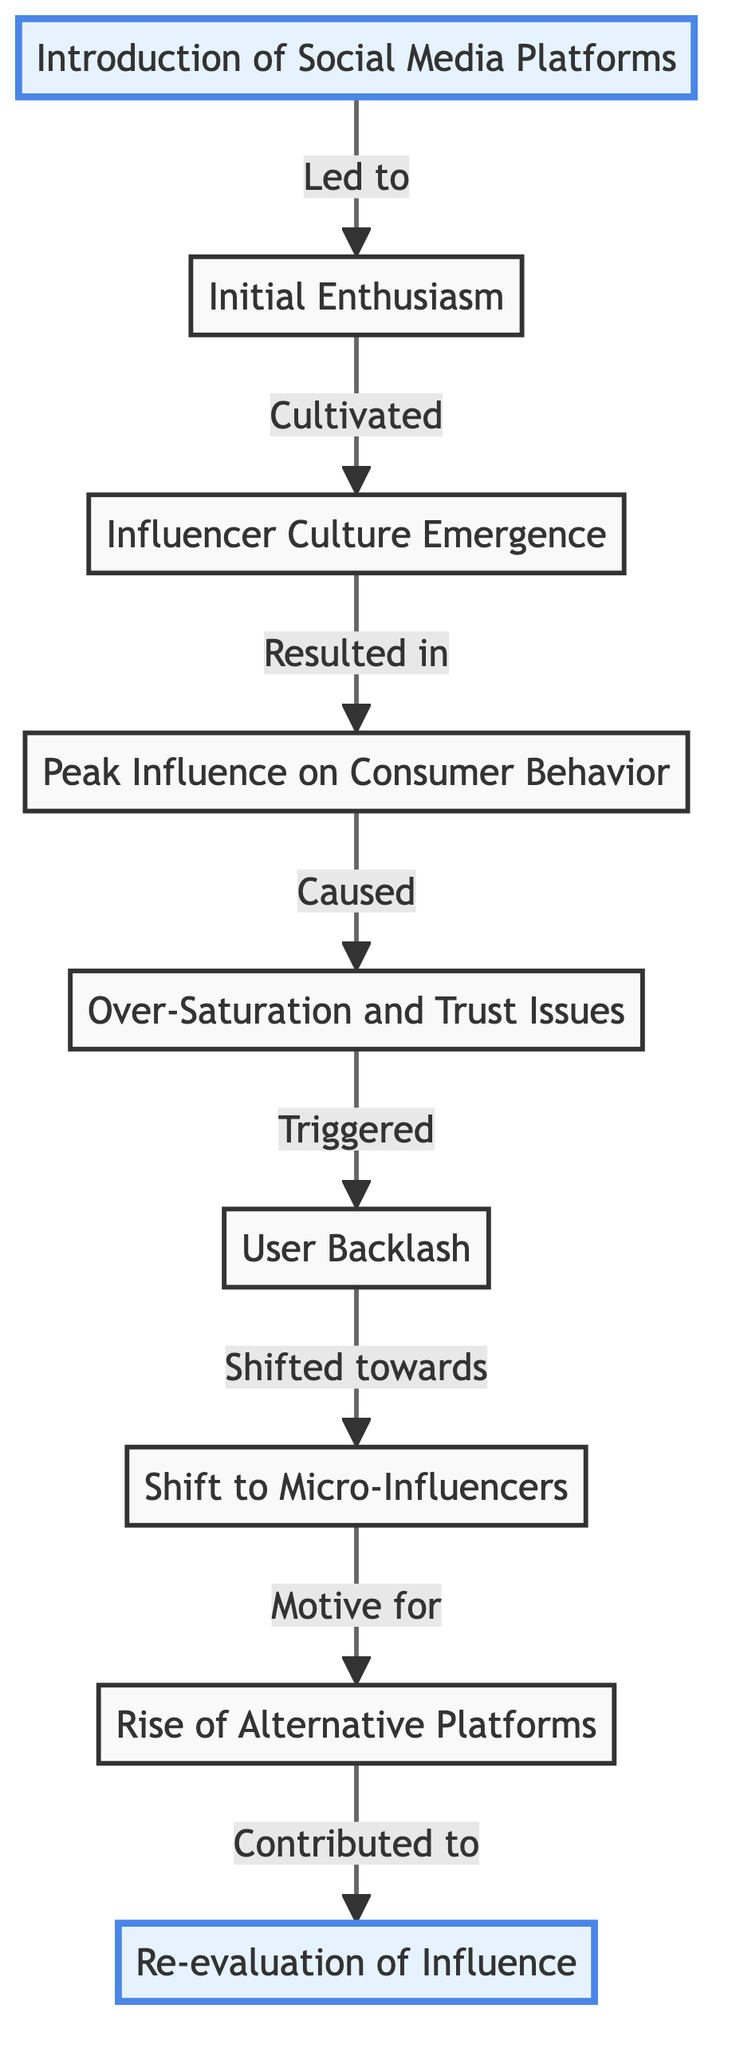What is the first node in the diagram? The first node in the diagram is labeled "Introduction of Social Media Platforms." It is the starting point from which the flow of influence begins.
Answer: Introduction of Social Media Platforms What follows "Peak Influence on Consumer Behavior"? After "Peak Influence on Consumer Behavior," the next node in the flow is "Over-Saturation and Trust Issues." This shows the sequence of events that follows the peak.
Answer: Over-Saturation and Trust Issues How many nodes are present in this diagram? The diagram contains 9 distinct nodes. Each node represents a stage in the rise and fall of social media influence on consumer behavior.
Answer: 9 Which node marks the shift towards involving smaller influencers? The node that signifies the shift towards involving smaller influencers is "Shift to Micro-Influencers." This indicates a change in strategy after user backlash.
Answer: Shift to Micro-Influencers What was the primary cause that led to user backlash? The primary cause that led to user backlash is "Over-Saturation and Trust Issues." This implies that consumers became overwhelmed and lost trust in social media advertising.
Answer: Over-Saturation and Trust Issues Which two nodes are connected directly by the phrase "Resulted in"? The nodes that are connected directly by the phrase "Resulted in" are "Influencer Culture Emergence" and "Peak Influence on Consumer Behavior." This shows the direct relationship between the emergence of influencers and their peak impact.
Answer: Influencer Culture Emergence and Peak Influence on Consumer Behavior What constitutes the final stage in the influence flow? The final stage in the influence flow is "Re-evaluation of Influence." This indicates a reflective phase after the peak and subsequent decline in influence.
Answer: Re-evaluation of Influence What was the main motive for rising alternative platforms? The main motive for the rise of alternative platforms is captured in the node "Rise of Alternative Platforms," which indicates a response to the shifting landscape of social media influence.
Answer: Rise of Alternative Platforms 